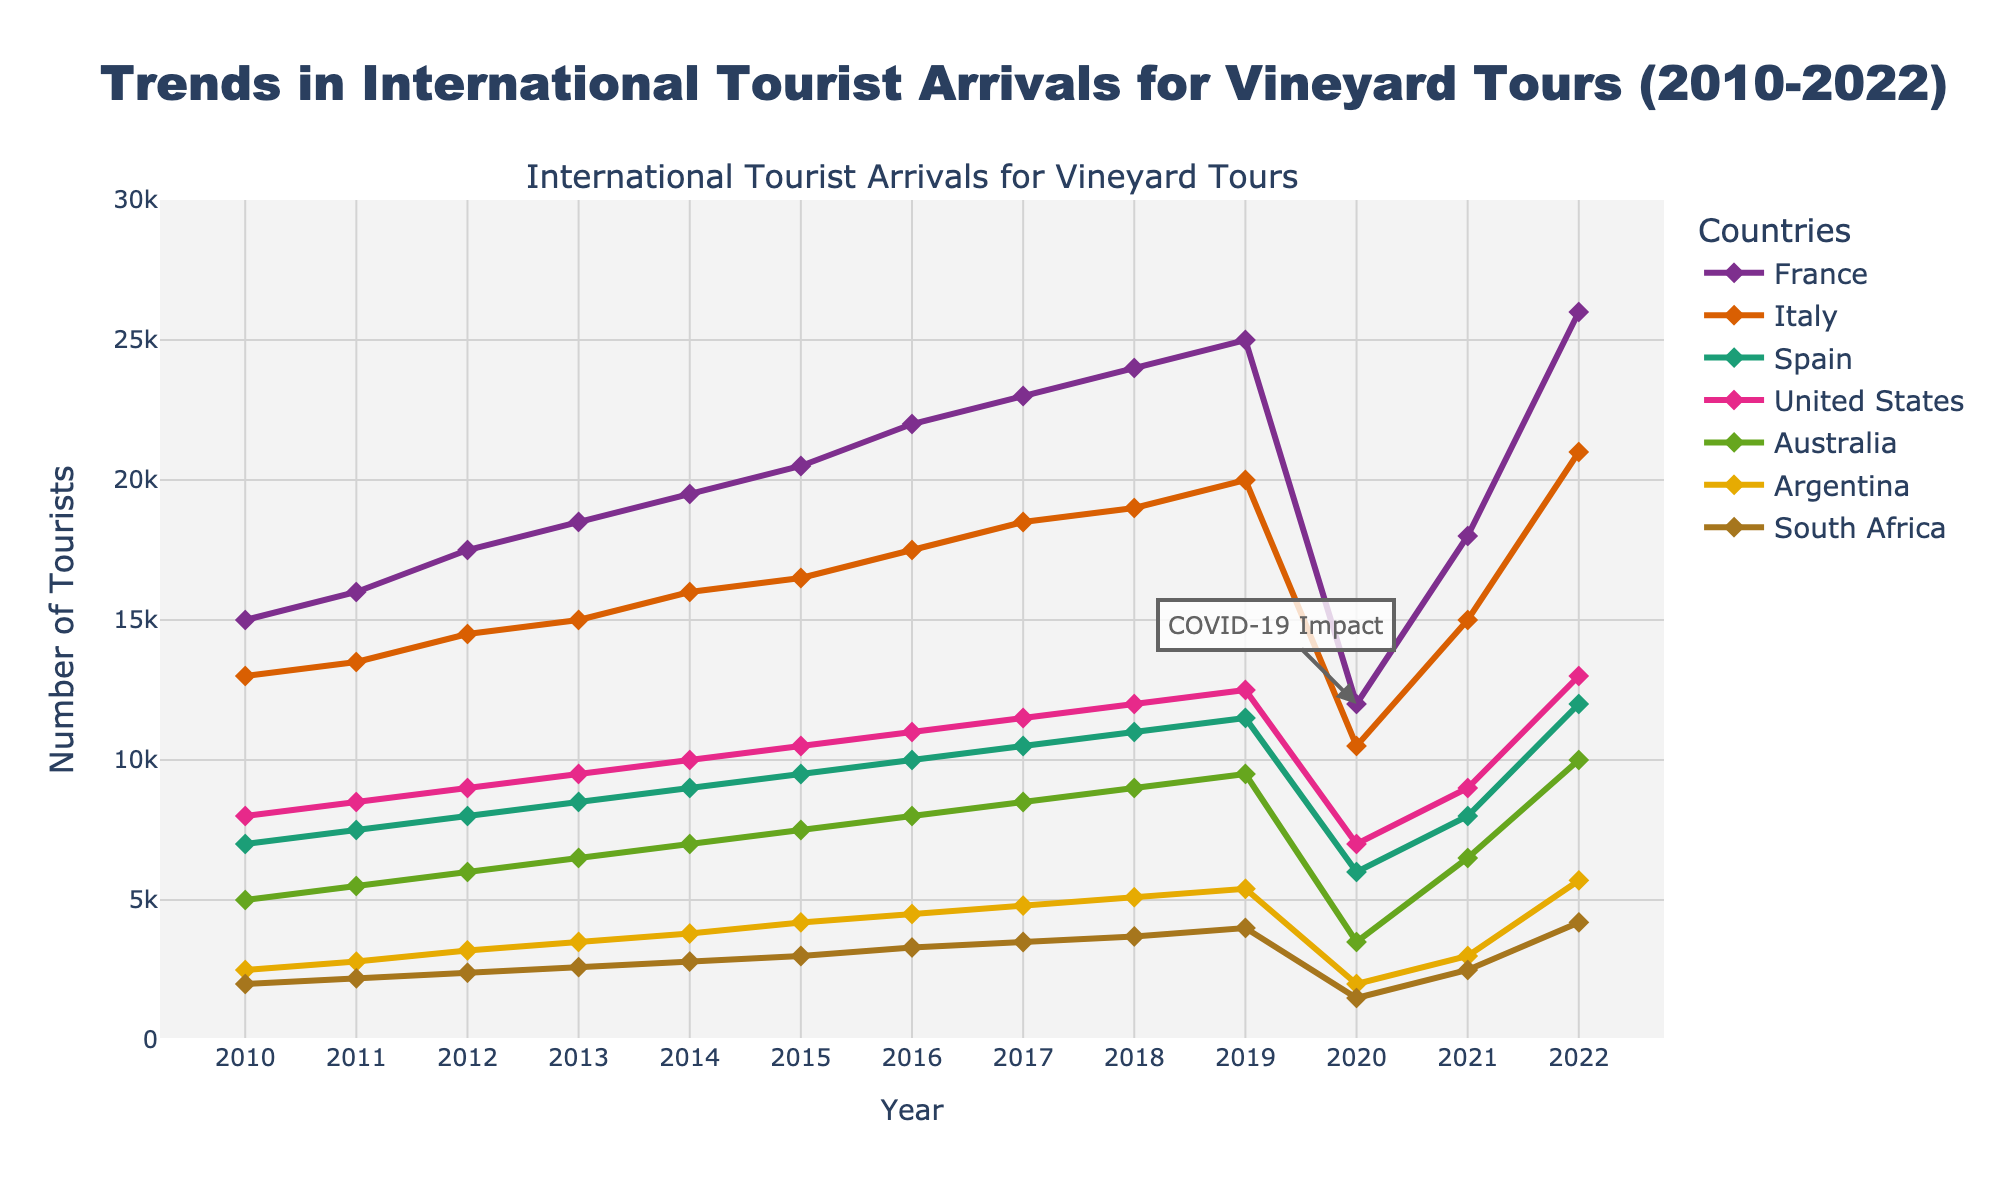What's the title of the plot? The title of the plot is displayed at the top, reading "Trends in International Tourist Arrivals for Vineyard Tours (2010-2022)".
Answer: Trends in International Tourist Arrivals for Vineyard Tours (2010-2022) Which year saw the highest number of tourists for France? By looking at the line representing France, the highest point is in the year 2022 with 26,000 tourists.
Answer: 2022 How did the number of tourists change for the United States from 2010 to 2019? The number of tourists in the United States increased from 8,000 in 2010 to 12,500 in 2019. This shows a consistent upward trend over the years.
Answer: Increased Which countries experienced a significant drop in tourists in 2020? By observing the graph, noticeable drops in tourist numbers in 2020 occurred in France, Italy, Spain, and the United States. France dropped to 12,000, Italy to 10,500, Spain to 6,000, and the United States to 7,000.
Answer: France, Italy, Spain, United States What is the average number of tourists for Australia between 2010 and 2019? Sum up the tourist numbers for Australia from 2010 to 2019 (5000 + 5500 + 6000 + 6500 + 7000 + 7500 + 8000 + 8500 + 9000 + 9500) = 72500, then divide by 10.
Answer: 7250 Which country had the least tourists in 2012 and how many were there? Checking the 2012 values, South Africa had the least tourists with a count of 2,400.
Answer: South Africa, 2400 How did the number of tourists in Argentina change from 2019 to 2022? From 2019 to 2022, Argentina's tourist number increased from 5,400 to 5,700.
Answer: Increased Which country had the most consistent increase in tourists from 2010 to 2019? By evaluating the trend lines, France had the most consistent increase in tourists, rising from 15,000 in 2010 to 25,000 in 2019.
Answer: France Which country showed the highest relative recovery in tourist numbers from 2020 to 2022? From 2020 to 2022, France showed the fastest recovery. In 2020, it had 12,000 tourists, and in 2022, it had 26,000 tourists, indicating a substantial rebound.
Answer: France 